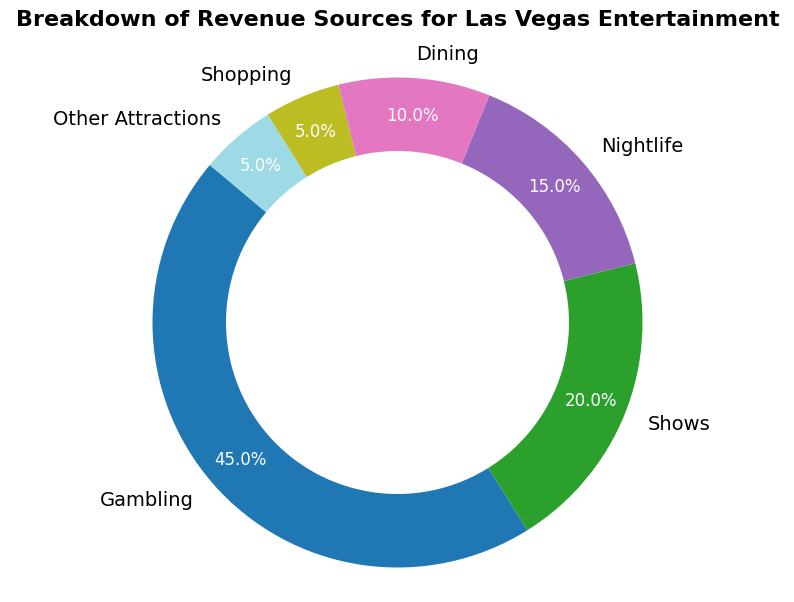what is the least contributing revenue source for Las Vegas entertainment? The figure shows various revenue sources broken down into percentages. The smallest segment on the pie chart, representing 5%, corresponds to both 'Shopping' and 'Other Attractions,' indicating these are the least contributing revenue sources.
Answer: Shopping and Other Attractions Which revenue source generates nearly half of Las Vegas' entertainment revenue? The largest segment on the pie chart represents 'Gambling,' which is at 45%, nearly half of the total revenue.
Answer: Gambling How much more revenue does gambling generate compared to shows? Gambling has 45% of the revenue, while shows have 20%. The difference is calculated as 45% - 20%.
Answer: 25% What's the combined revenue percentage of dining, shopping, and other attractions? Summing up the percentages for dining (10%), shopping (5%), and other attractions (5%) gives us 10% + 5% + 5%.
Answer: 20% If the revenue from nightlife were to increase by 10%, what would be the new percentage for nightlife? Nightlife currently contributes 15%. Increasing this by 10% would be calculated as 15% + 10%.
Answer: 25% Which entertainment source has a revenue percentage that is a quarter of gambling? A quarter of gambling's revenue percentage (45%) is 45% / 4, which equals 11.25%. The closest category to this value is 'Dining' at 10%.
Answer: Dining Between dining and nightlife, which source contributes more to the revenue, and by how much? The pie chart indicates dining has 10%, and nightlife has 15%. The difference is 15% - 10%.
Answer: Nightlife by 5% Which two entertainment sources together make up a quarter of the total revenue? Shows contribute 20%, and shopping contributes 5%. Adding these together gives 20% + 5%, which equals 25%.
Answer: Shows and Shopping What percentage of the revenue do shows and nightlife contribute compared to gambling? Shows contribute 20% and nightlife 15%. Adding these together gives 20% + 15% = 35%. Gambling contributes 45%. The difference is 45% - 35%.
Answer: 10% less than Gambling 